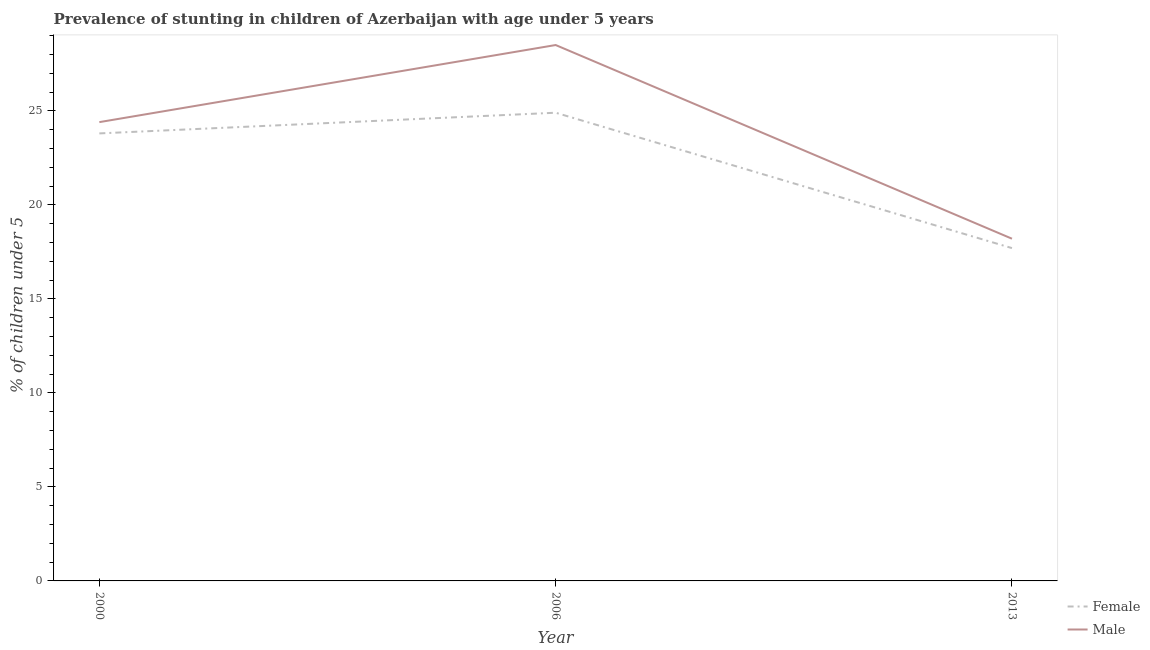How many different coloured lines are there?
Give a very brief answer. 2. Is the number of lines equal to the number of legend labels?
Offer a terse response. Yes. What is the percentage of stunted female children in 2013?
Offer a terse response. 17.7. Across all years, what is the minimum percentage of stunted male children?
Offer a very short reply. 18.2. In which year was the percentage of stunted female children maximum?
Provide a succinct answer. 2006. In which year was the percentage of stunted female children minimum?
Ensure brevity in your answer.  2013. What is the total percentage of stunted female children in the graph?
Your answer should be very brief. 66.4. What is the difference between the percentage of stunted male children in 2000 and that in 2006?
Make the answer very short. -4.1. What is the average percentage of stunted male children per year?
Offer a very short reply. 23.7. In the year 2006, what is the difference between the percentage of stunted male children and percentage of stunted female children?
Give a very brief answer. 3.6. In how many years, is the percentage of stunted female children greater than 3 %?
Offer a very short reply. 3. What is the ratio of the percentage of stunted male children in 2000 to that in 2013?
Ensure brevity in your answer.  1.34. Is the percentage of stunted female children in 2000 less than that in 2013?
Ensure brevity in your answer.  No. Is the difference between the percentage of stunted male children in 2006 and 2013 greater than the difference between the percentage of stunted female children in 2006 and 2013?
Offer a terse response. Yes. What is the difference between the highest and the second highest percentage of stunted male children?
Make the answer very short. 4.1. What is the difference between the highest and the lowest percentage of stunted male children?
Give a very brief answer. 10.3. Does the percentage of stunted male children monotonically increase over the years?
Provide a succinct answer. No. Is the percentage of stunted male children strictly greater than the percentage of stunted female children over the years?
Offer a very short reply. Yes. Is the percentage of stunted male children strictly less than the percentage of stunted female children over the years?
Your answer should be compact. No. How many lines are there?
Give a very brief answer. 2. What is the difference between two consecutive major ticks on the Y-axis?
Give a very brief answer. 5. Does the graph contain any zero values?
Provide a short and direct response. No. Does the graph contain grids?
Provide a succinct answer. No. What is the title of the graph?
Your answer should be compact. Prevalence of stunting in children of Azerbaijan with age under 5 years. Does "Largest city" appear as one of the legend labels in the graph?
Your answer should be compact. No. What is the label or title of the Y-axis?
Provide a short and direct response.  % of children under 5. What is the  % of children under 5 of Female in 2000?
Make the answer very short. 23.8. What is the  % of children under 5 of Male in 2000?
Offer a very short reply. 24.4. What is the  % of children under 5 in Female in 2006?
Your answer should be compact. 24.9. What is the  % of children under 5 of Female in 2013?
Your answer should be very brief. 17.7. What is the  % of children under 5 in Male in 2013?
Ensure brevity in your answer.  18.2. Across all years, what is the maximum  % of children under 5 in Female?
Provide a succinct answer. 24.9. Across all years, what is the minimum  % of children under 5 in Female?
Provide a short and direct response. 17.7. Across all years, what is the minimum  % of children under 5 in Male?
Offer a terse response. 18.2. What is the total  % of children under 5 of Female in the graph?
Your response must be concise. 66.4. What is the total  % of children under 5 of Male in the graph?
Offer a very short reply. 71.1. What is the difference between the  % of children under 5 of Male in 2000 and that in 2006?
Provide a short and direct response. -4.1. What is the difference between the  % of children under 5 of Female in 2000 and that in 2013?
Keep it short and to the point. 6.1. What is the difference between the  % of children under 5 in Female in 2006 and that in 2013?
Provide a short and direct response. 7.2. What is the difference between the  % of children under 5 in Male in 2006 and that in 2013?
Offer a terse response. 10.3. What is the difference between the  % of children under 5 in Female in 2000 and the  % of children under 5 in Male in 2013?
Provide a short and direct response. 5.6. What is the difference between the  % of children under 5 in Female in 2006 and the  % of children under 5 in Male in 2013?
Your answer should be compact. 6.7. What is the average  % of children under 5 in Female per year?
Provide a succinct answer. 22.13. What is the average  % of children under 5 in Male per year?
Provide a succinct answer. 23.7. In the year 2000, what is the difference between the  % of children under 5 in Female and  % of children under 5 in Male?
Give a very brief answer. -0.6. In the year 2006, what is the difference between the  % of children under 5 in Female and  % of children under 5 in Male?
Keep it short and to the point. -3.6. In the year 2013, what is the difference between the  % of children under 5 of Female and  % of children under 5 of Male?
Your answer should be compact. -0.5. What is the ratio of the  % of children under 5 in Female in 2000 to that in 2006?
Make the answer very short. 0.96. What is the ratio of the  % of children under 5 in Male in 2000 to that in 2006?
Provide a succinct answer. 0.86. What is the ratio of the  % of children under 5 of Female in 2000 to that in 2013?
Offer a very short reply. 1.34. What is the ratio of the  % of children under 5 of Male in 2000 to that in 2013?
Offer a terse response. 1.34. What is the ratio of the  % of children under 5 of Female in 2006 to that in 2013?
Your response must be concise. 1.41. What is the ratio of the  % of children under 5 in Male in 2006 to that in 2013?
Your answer should be compact. 1.57. What is the difference between the highest and the second highest  % of children under 5 in Female?
Your answer should be compact. 1.1. What is the difference between the highest and the second highest  % of children under 5 in Male?
Your response must be concise. 4.1. 